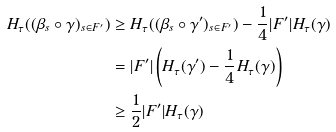<formula> <loc_0><loc_0><loc_500><loc_500>H _ { \tau } ( ( \beta _ { s } \circ \gamma ) _ { s \in F ^ { \prime } } ) & \geq H _ { \tau } ( ( \beta _ { s } \circ \gamma ^ { \prime } ) _ { s \in F ^ { \prime } } ) - \frac { 1 } { 4 } | F ^ { \prime } | H _ { \tau } ( \gamma ) \\ & = | F ^ { \prime } | \left ( H _ { \tau } ( \gamma ^ { \prime } ) - \frac { 1 } { 4 } H _ { \tau } ( \gamma ) \right ) \\ & \geq \frac { 1 } { 2 } | F ^ { \prime } | H _ { \tau } ( \gamma )</formula> 